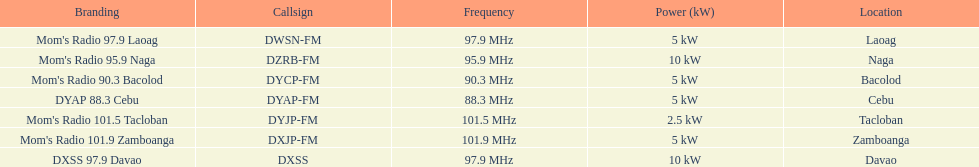Parse the full table. {'header': ['Branding', 'Callsign', 'Frequency', 'Power (kW)', 'Location'], 'rows': [["Mom's Radio 97.9 Laoag", 'DWSN-FM', '97.9\xa0MHz', '5\xa0kW', 'Laoag'], ["Mom's Radio 95.9 Naga", 'DZRB-FM', '95.9\xa0MHz', '10\xa0kW', 'Naga'], ["Mom's Radio 90.3 Bacolod", 'DYCP-FM', '90.3\xa0MHz', '5\xa0kW', 'Bacolod'], ['DYAP 88.3 Cebu', 'DYAP-FM', '88.3\xa0MHz', '5\xa0kW', 'Cebu'], ["Mom's Radio 101.5 Tacloban", 'DYJP-FM', '101.5\xa0MHz', '2.5\xa0kW', 'Tacloban'], ["Mom's Radio 101.9 Zamboanga", 'DXJP-FM', '101.9\xa0MHz', '5\xa0kW', 'Zamboanga'], ['DXSS 97.9 Davao', 'DXSS', '97.9\xa0MHz', '10\xa0kW', 'Davao']]} How many times is the frequency greater than 95? 5. 